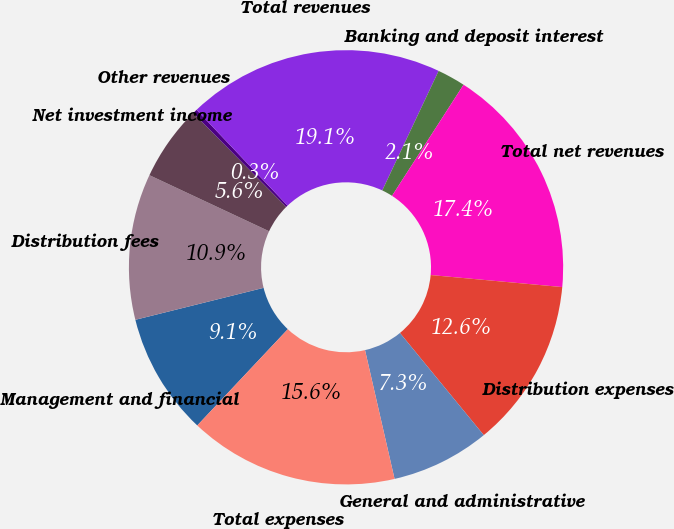Convert chart to OTSL. <chart><loc_0><loc_0><loc_500><loc_500><pie_chart><fcel>Management and financial<fcel>Distribution fees<fcel>Net investment income<fcel>Other revenues<fcel>Total revenues<fcel>Banking and deposit interest<fcel>Total net revenues<fcel>Distribution expenses<fcel>General and administrative<fcel>Total expenses<nl><fcel>9.1%<fcel>10.86%<fcel>5.6%<fcel>0.34%<fcel>19.1%<fcel>2.09%<fcel>17.35%<fcel>12.61%<fcel>7.35%<fcel>15.6%<nl></chart> 